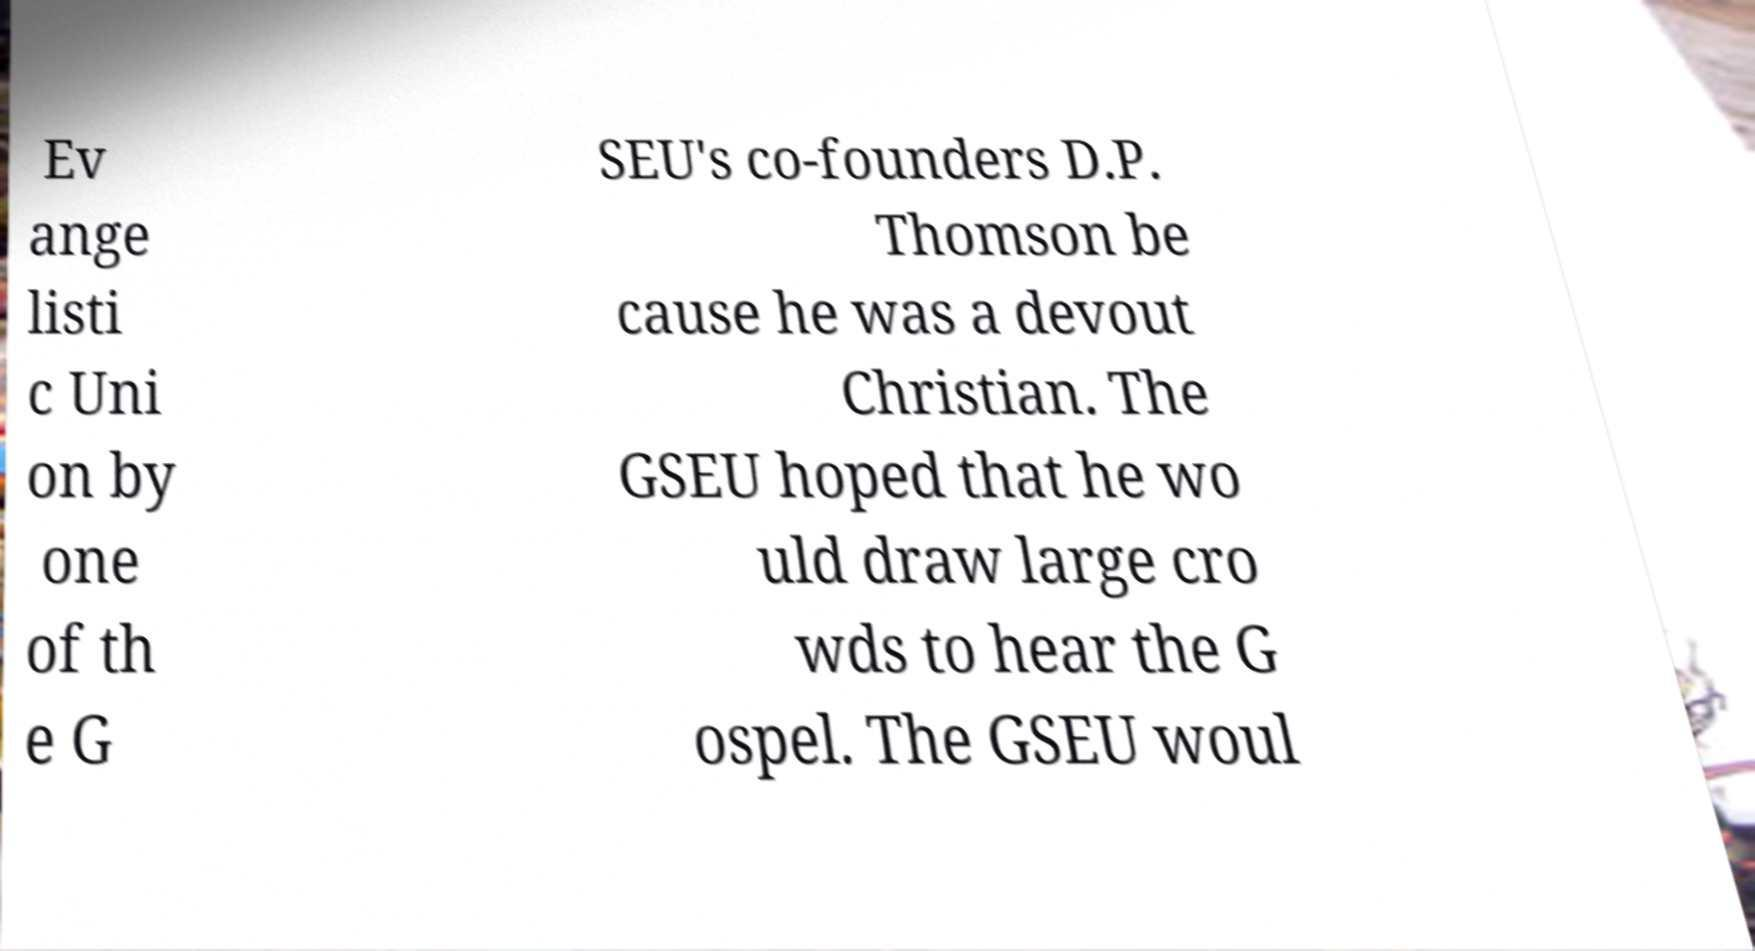Could you assist in decoding the text presented in this image and type it out clearly? Ev ange listi c Uni on by one of th e G SEU's co-founders D.P. Thomson be cause he was a devout Christian. The GSEU hoped that he wo uld draw large cro wds to hear the G ospel. The GSEU woul 